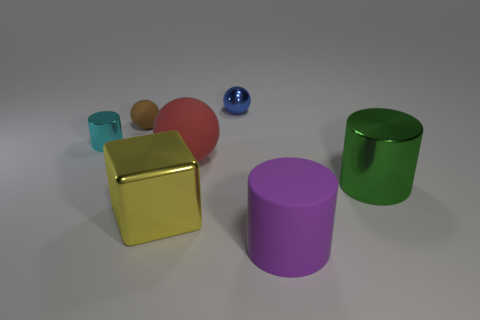Add 1 large green shiny blocks. How many objects exist? 8 Subtract all cubes. How many objects are left? 6 Subtract all tiny blue balls. Subtract all big yellow metal cubes. How many objects are left? 5 Add 3 small cylinders. How many small cylinders are left? 4 Add 7 big purple cylinders. How many big purple cylinders exist? 8 Subtract 0 gray cubes. How many objects are left? 7 